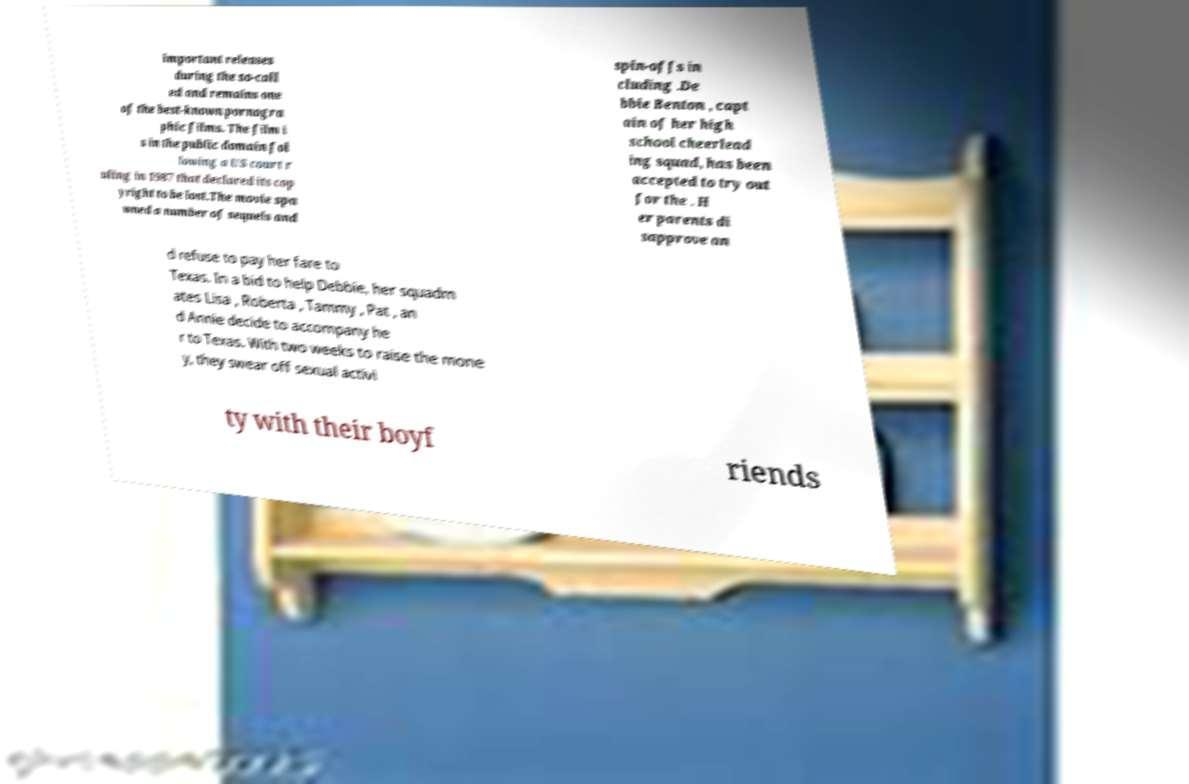Could you extract and type out the text from this image? important releases during the so-call ed and remains one of the best-known pornogra phic films. The film i s in the public domain fol lowing a US court r uling in 1987 that declared its cop yright to be lost.The movie spa wned a number of sequels and spin-offs in cluding .De bbie Benton , capt ain of her high school cheerlead ing squad, has been accepted to try out for the . H er parents di sapprove an d refuse to pay her fare to Texas. In a bid to help Debbie, her squadm ates Lisa , Roberta , Tammy , Pat , an d Annie decide to accompany he r to Texas. With two weeks to raise the mone y, they swear off sexual activi ty with their boyf riends 